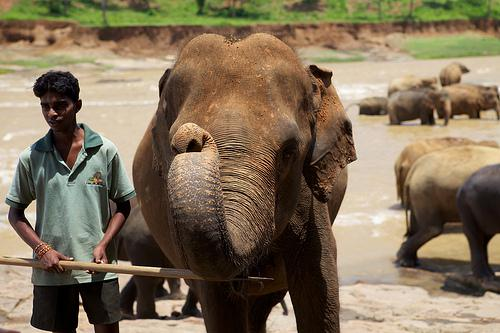Question: who took the picture?
Choices:
A. Man.
B. Woman.
C. Boy.
D. Girl.
Answer with the letter. Answer: A Question: why does he have a pole?
Choices:
A. To control the gondola.
B. To control the elephant.
C. To tightrope walk.
D. To pole vault.
Answer with the letter. Answer: B Question: what is green?
Choices:
A. Pants.
B. Belt.
C. Shirt.
D. Hat.
Answer with the letter. Answer: C Question: what is brown?
Choices:
A. Grass.
B. Elephant.
C. Snake.
D. Horse.
Answer with the letter. Answer: B 